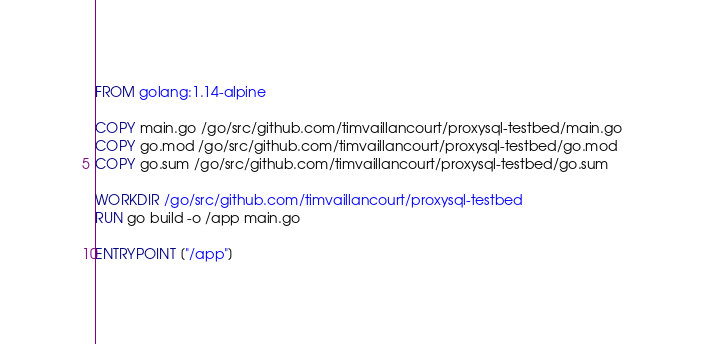Convert code to text. <code><loc_0><loc_0><loc_500><loc_500><_Dockerfile_>FROM golang:1.14-alpine

COPY main.go /go/src/github.com/timvaillancourt/proxysql-testbed/main.go
COPY go.mod /go/src/github.com/timvaillancourt/proxysql-testbed/go.mod
COPY go.sum /go/src/github.com/timvaillancourt/proxysql-testbed/go.sum

WORKDIR /go/src/github.com/timvaillancourt/proxysql-testbed
RUN go build -o /app main.go

ENTRYPOINT ["/app"]
</code> 